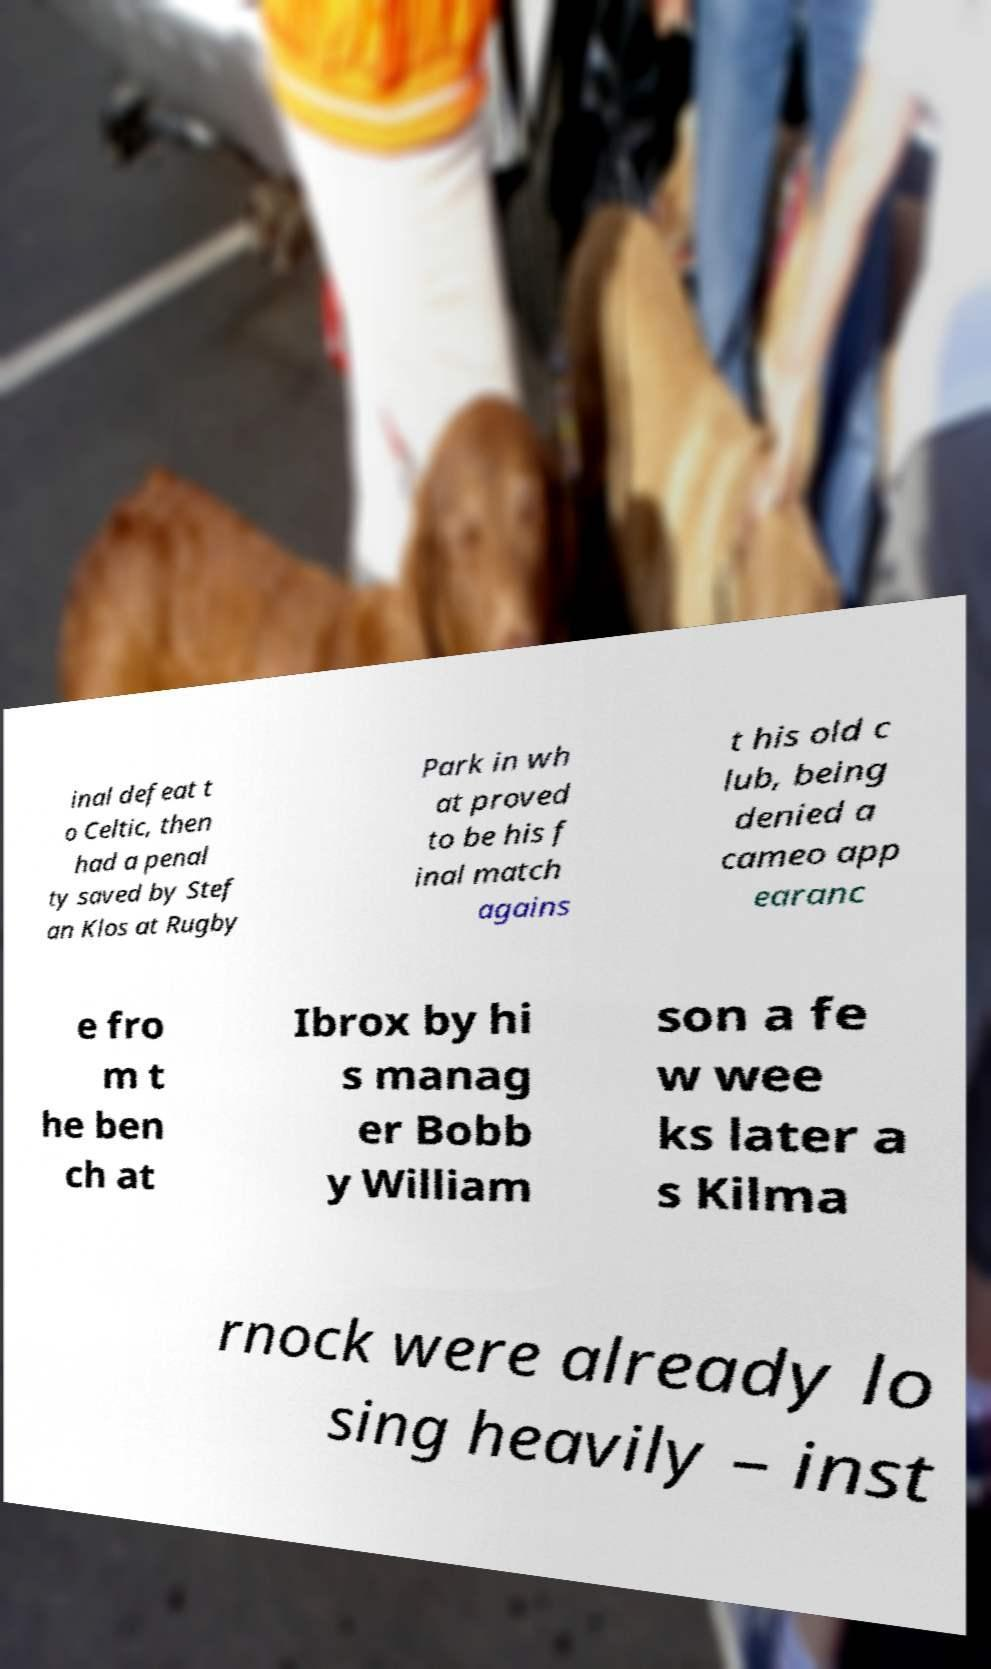For documentation purposes, I need the text within this image transcribed. Could you provide that? inal defeat t o Celtic, then had a penal ty saved by Stef an Klos at Rugby Park in wh at proved to be his f inal match agains t his old c lub, being denied a cameo app earanc e fro m t he ben ch at Ibrox by hi s manag er Bobb y William son a fe w wee ks later a s Kilma rnock were already lo sing heavily – inst 